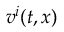<formula> <loc_0><loc_0><loc_500><loc_500>v ^ { i } ( t , x )</formula> 